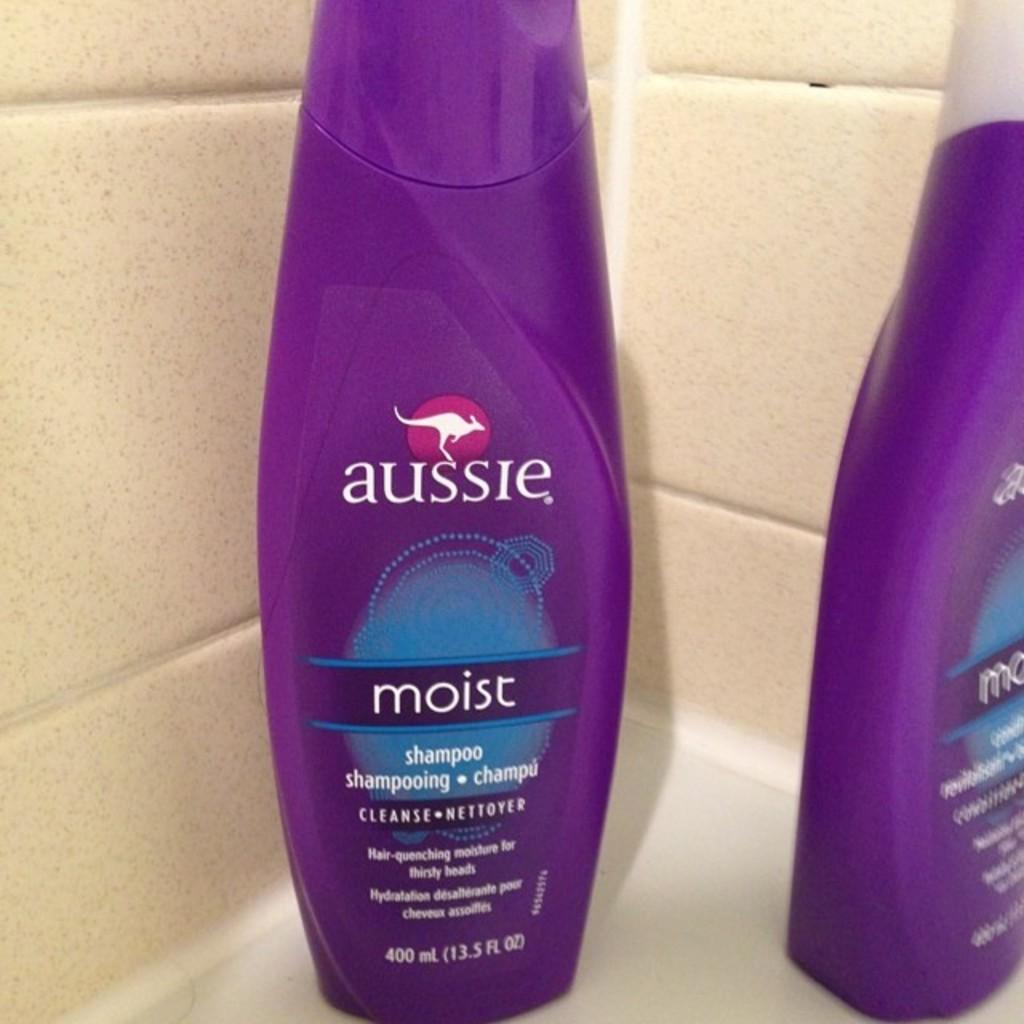<image>
Describe the image concisely. Two purple bottles of Aussie Moist hair product. 